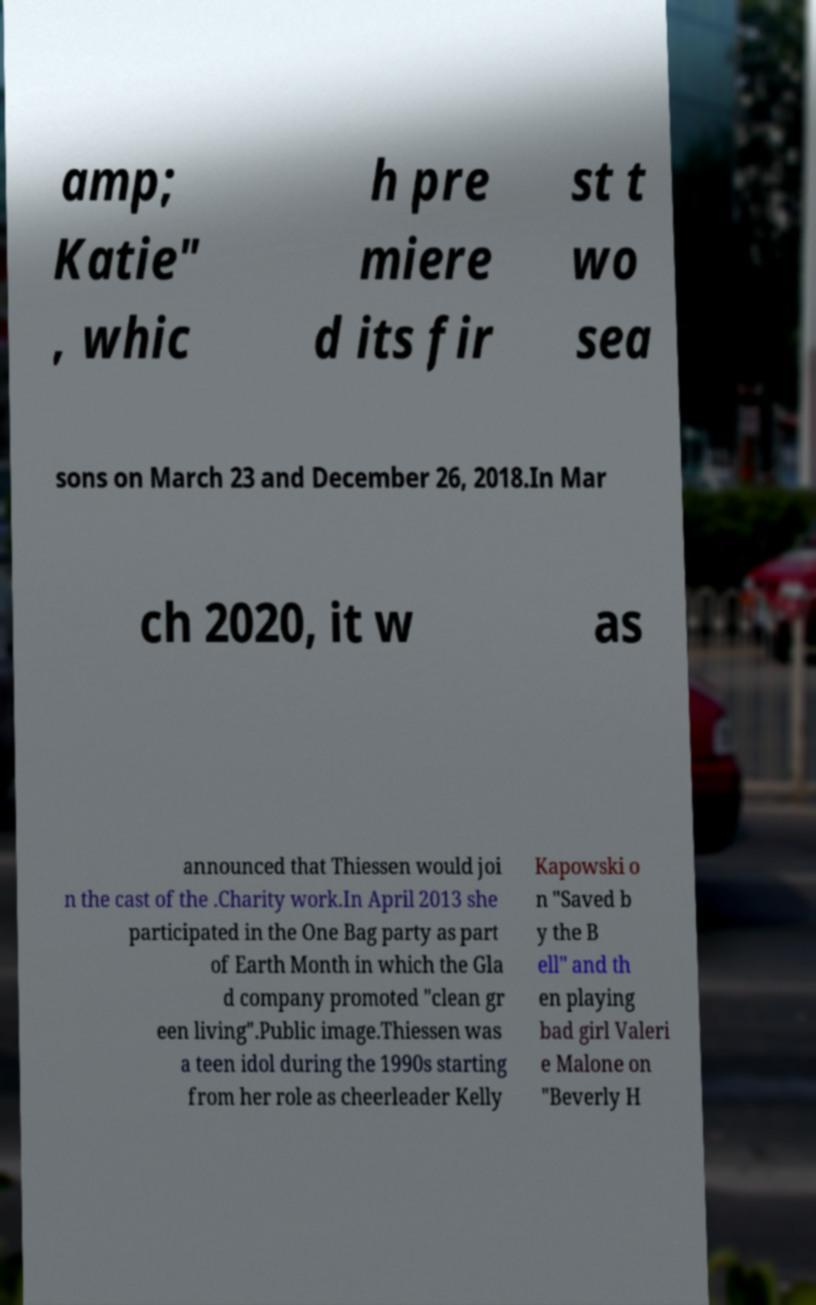Can you accurately transcribe the text from the provided image for me? amp; Katie" , whic h pre miere d its fir st t wo sea sons on March 23 and December 26, 2018.In Mar ch 2020, it w as announced that Thiessen would joi n the cast of the .Charity work.In April 2013 she participated in the One Bag party as part of Earth Month in which the Gla d company promoted "clean gr een living".Public image.Thiessen was a teen idol during the 1990s starting from her role as cheerleader Kelly Kapowski o n "Saved b y the B ell" and th en playing bad girl Valeri e Malone on "Beverly H 